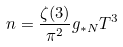Convert formula to latex. <formula><loc_0><loc_0><loc_500><loc_500>n = \frac { \zeta ( 3 ) } { \pi ^ { 2 } } g _ { * N } T ^ { 3 }</formula> 